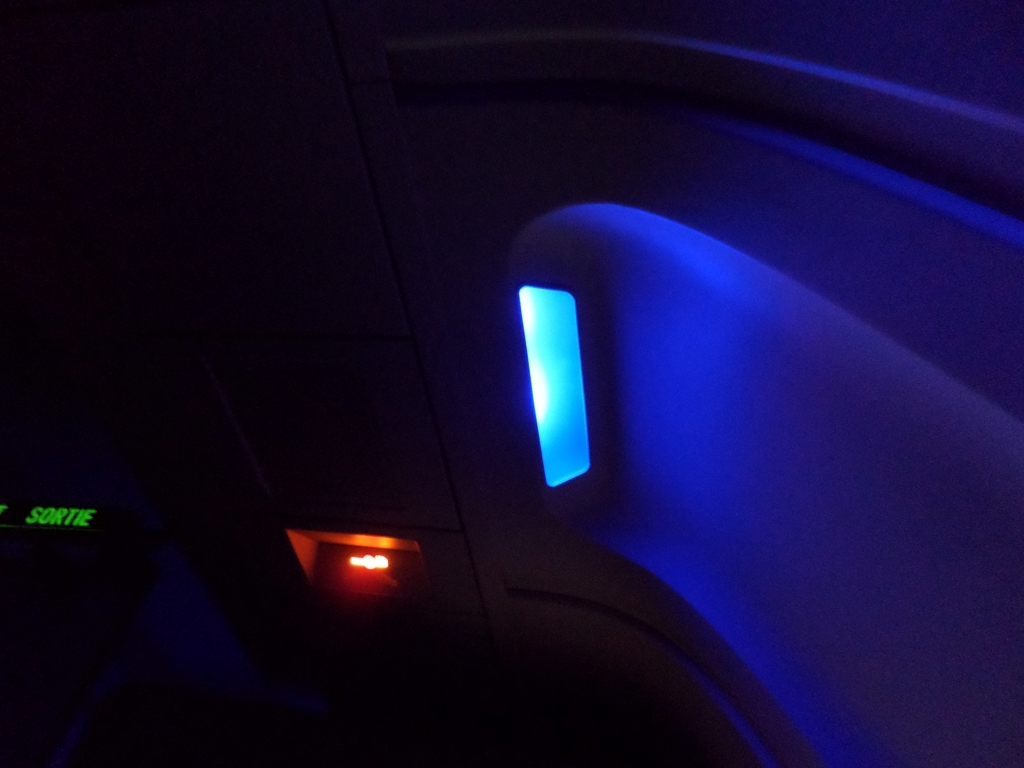What is the overall clarity of the image? The image clarity is relatively low due to the dim lighting and possible motion blur, which affects the sharpness of the details. The main focus appears to be a blue light feature, possibly part of an airplane's interior, which stands out against the darker background. 